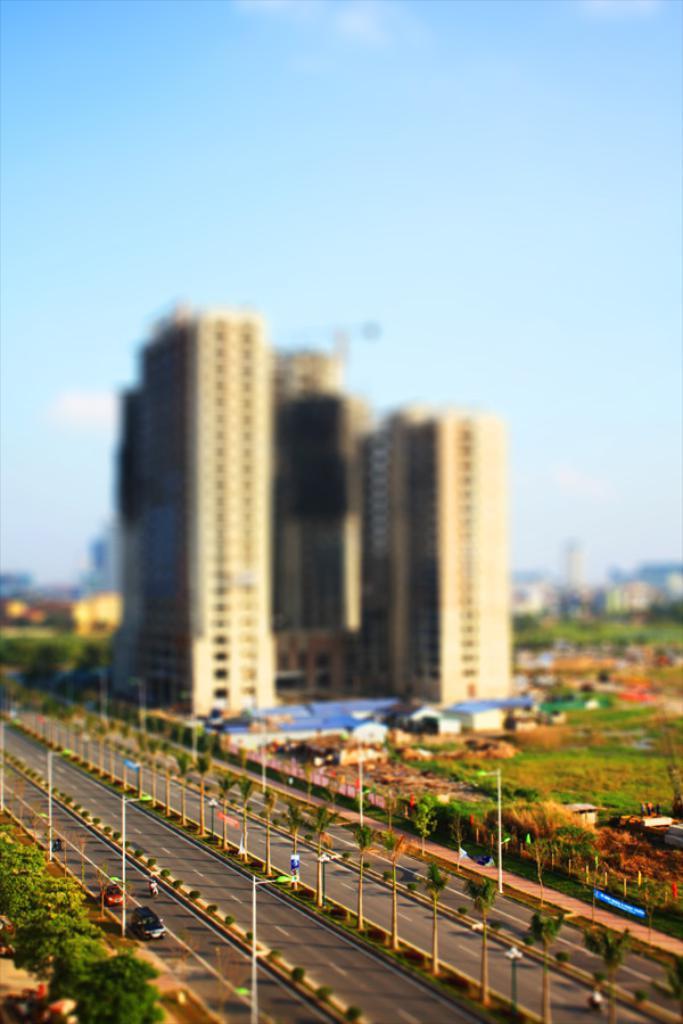Describe this image in one or two sentences. In this image at the bottom there is a road, poles, vehicles, trees, plants, and there is a footpath. And in the background there are buildings, towers, plants and some houses. At the top there is sky. 